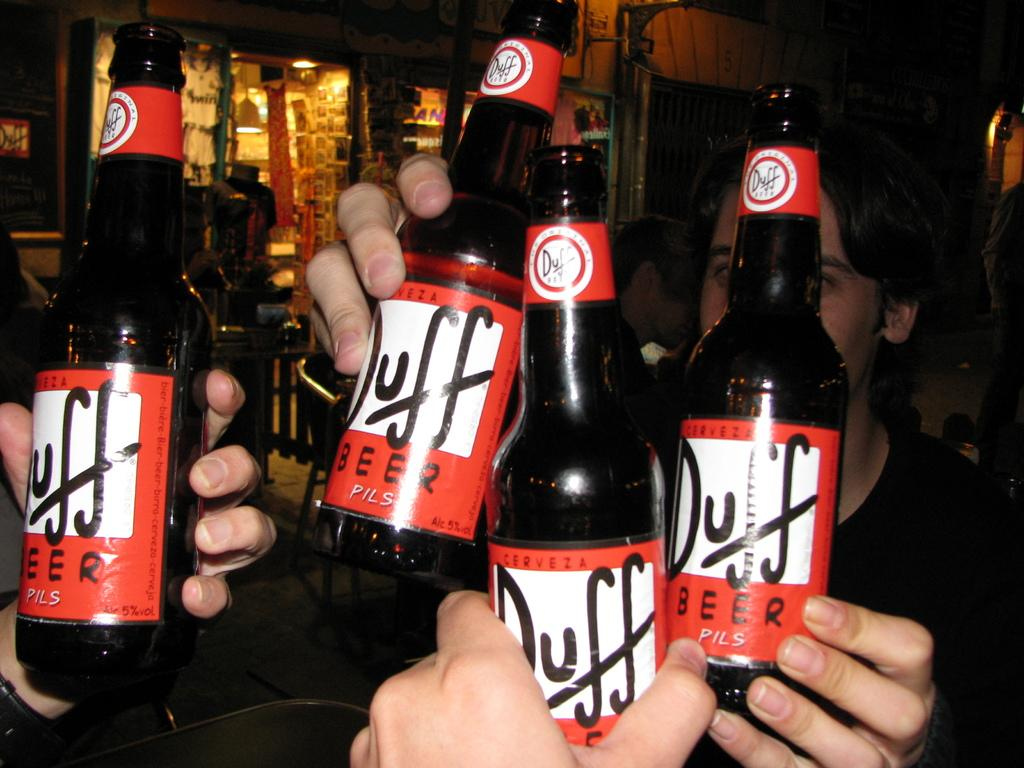<image>
Describe the image concisely. People holding up four  bottles of Duff beer 